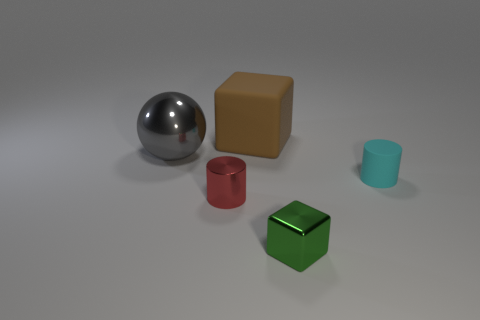Add 1 small brown metal cubes. How many objects exist? 6 Subtract all cubes. How many objects are left? 3 Subtract 0 gray blocks. How many objects are left? 5 Subtract all big red metallic spheres. Subtract all metal spheres. How many objects are left? 4 Add 1 red things. How many red things are left? 2 Add 1 red cylinders. How many red cylinders exist? 2 